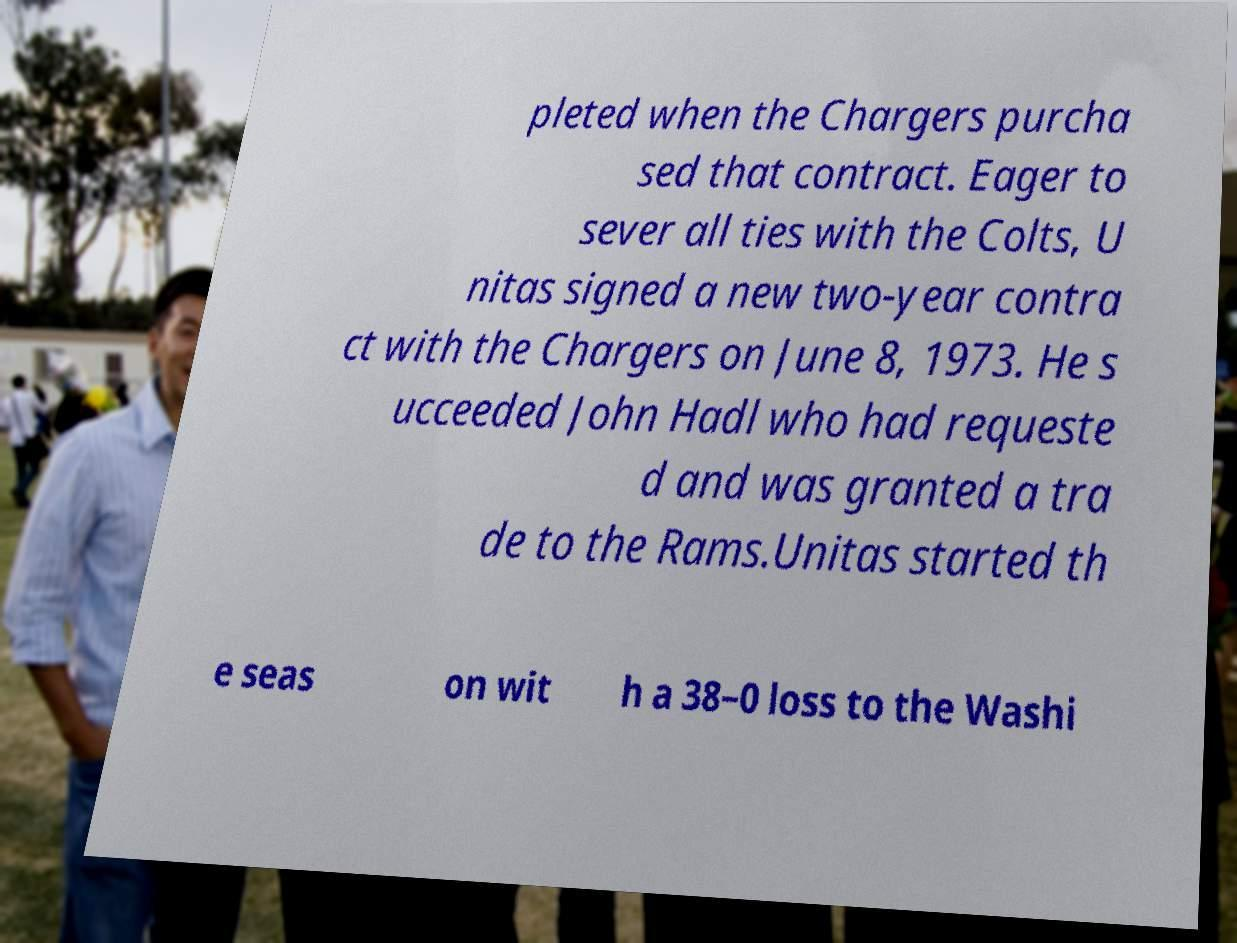Could you extract and type out the text from this image? pleted when the Chargers purcha sed that contract. Eager to sever all ties with the Colts, U nitas signed a new two-year contra ct with the Chargers on June 8, 1973. He s ucceeded John Hadl who had requeste d and was granted a tra de to the Rams.Unitas started th e seas on wit h a 38–0 loss to the Washi 